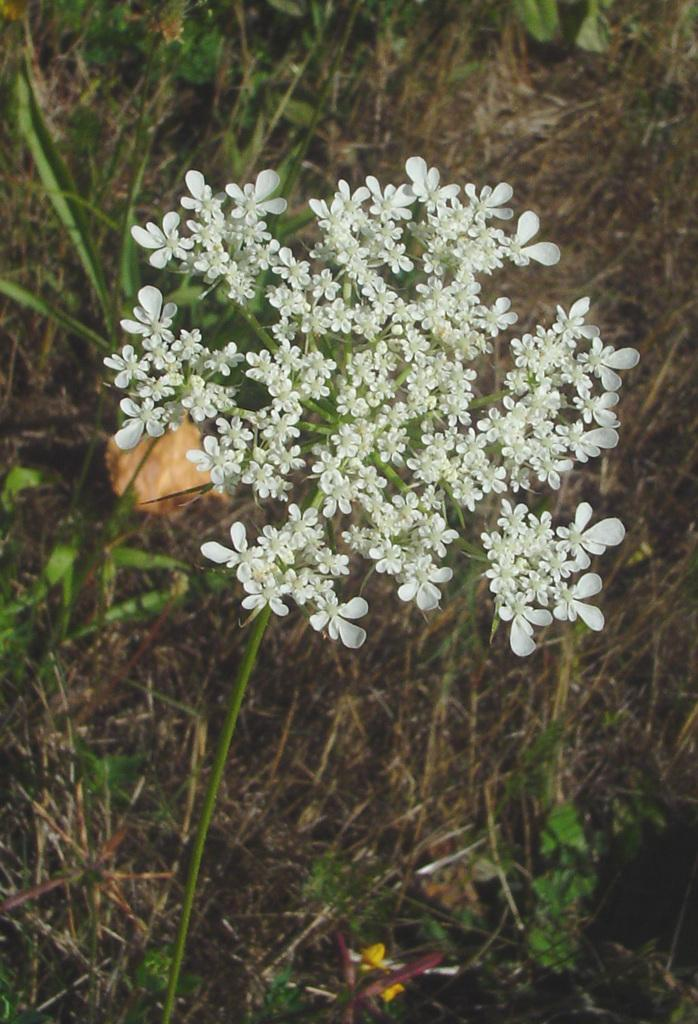What type of flowers can be seen in the image? There are white colored flowers in the image. What is the flowers attached to? The flowers belong to a plant. What else can be seen in the background of the image? There are other plants visible in the background of the image. Where are the plants located? The plants are on the ground. What type of trick can be performed with the calendar in the image? There is no calendar present in the image, so no trick can be performed with it. 